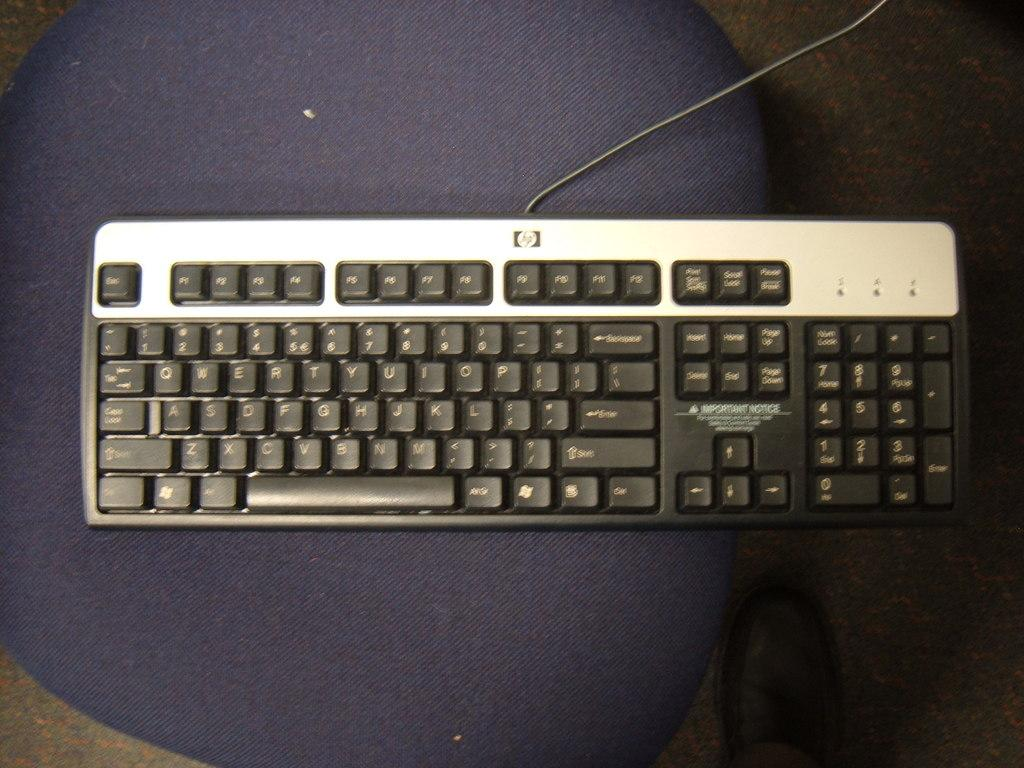What is the main object in the image? There is a keyboard in the image. What is the keyboard placed on? The keyboard is placed on a blue surface. Can you describe any other objects visible in the image? There is a black shoe visible at the bottom portion of the image. What type of pen is being used to write on the keyboard in the image? There is no pen or writing on the keyboard in the image. 